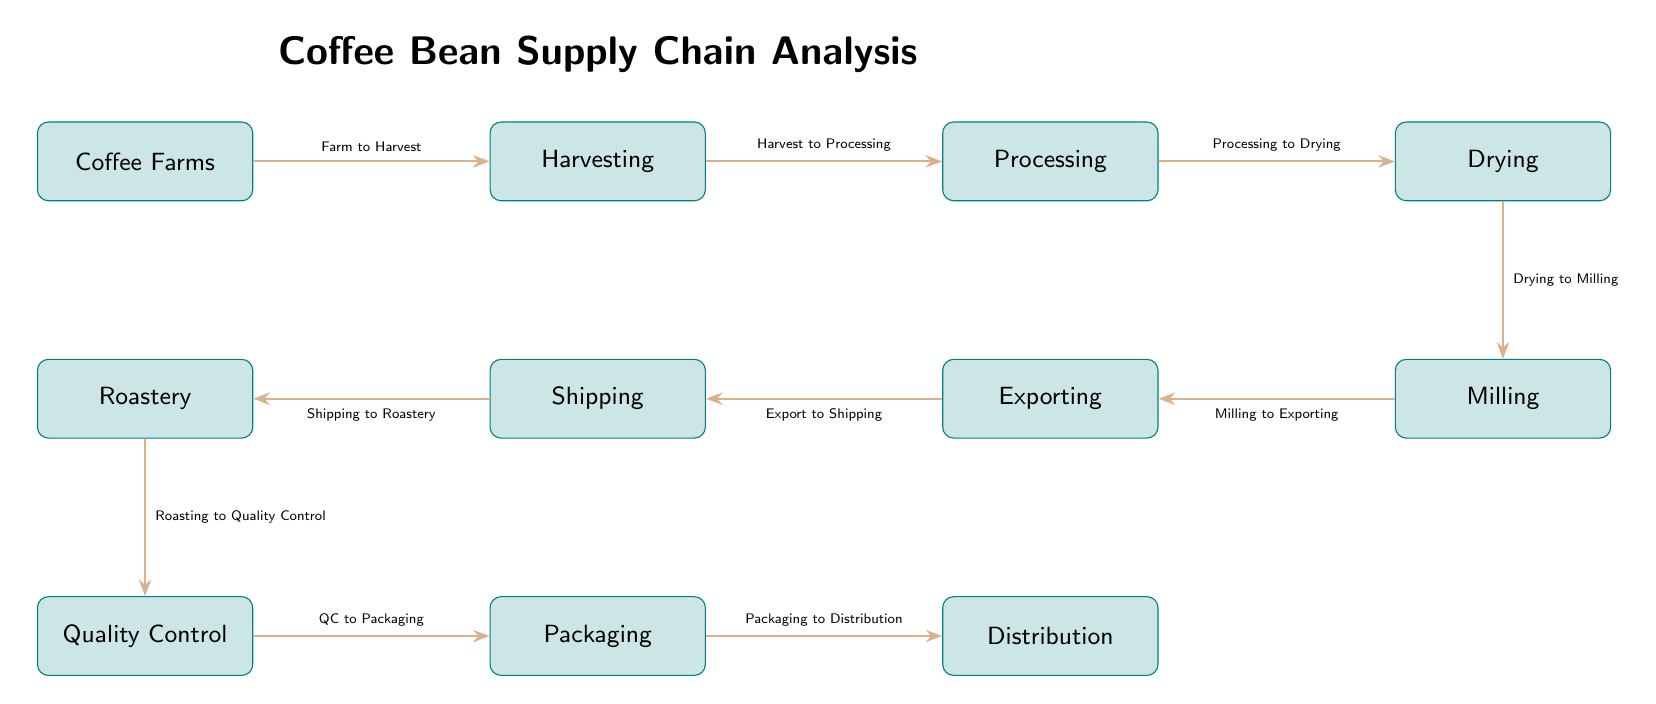What is the first step in the coffee bean supply chain? The first node in the diagram, which represents the starting point of the supply chain, is labeled "Coffee Farms."
Answer: Coffee Farms How many nodes are there in total in the supply chain? Counting all the distinct steps in the diagram from "Coffee Farms" to "Distribution," there are eleven nodes represented.
Answer: 11 What process occurs immediately after processing? The diagram shows that the step following "Processing" is "Drying," indicating the sequential nature of these operations.
Answer: Drying What is the relationship between "Milling" and "Exporting"? According to the diagram's flow, the edge from "Milling" to "Exporting" is labeled "Milling to Exporting," clearly defining the relationship.
Answer: Milling to Exporting Which step has "Quality Control" directly after it? From the diagram, "Roastery" is the node that directly connects to "Quality Control," indicating that quality checks follow roasting operations.
Answer: Roastery What occurs between "Shipping" and "Roastery"? The arrow drawn from "Shipping" to "Roastery" is labeled "Shipping to Roastery," which details what happens during this part of the supply chain.
Answer: Shipping to Roastery Which step in the supply chain is related to packaging? The diagram indicates that "Quality Control" feeds into "Packaging," showing the order of operations concerning the packaging process.
Answer: Quality Control What is the last step in the coffee bean supply chain? The last node in the diagram, representing the final stage of distribution of the coffee beans, is labeled "Distribution."
Answer: Distribution What is the flow direction of the coffee bean supply chain? The diagram illustrates a left-to-right flow direction, starting from "Coffee Farms" and proceeding to "Distribution."
Answer: Left to right 